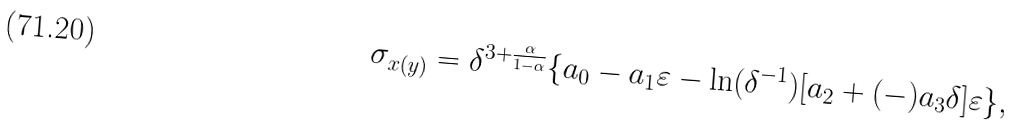Convert formula to latex. <formula><loc_0><loc_0><loc_500><loc_500>\sigma _ { x ( y ) } = \delta ^ { 3 + \frac { \alpha } { 1 - \alpha } } \{ a _ { 0 } - a _ { 1 } \varepsilon - \ln ( \delta ^ { - 1 } ) [ a _ { 2 } + ( - ) a _ { 3 } \delta ] \varepsilon \} ,</formula> 